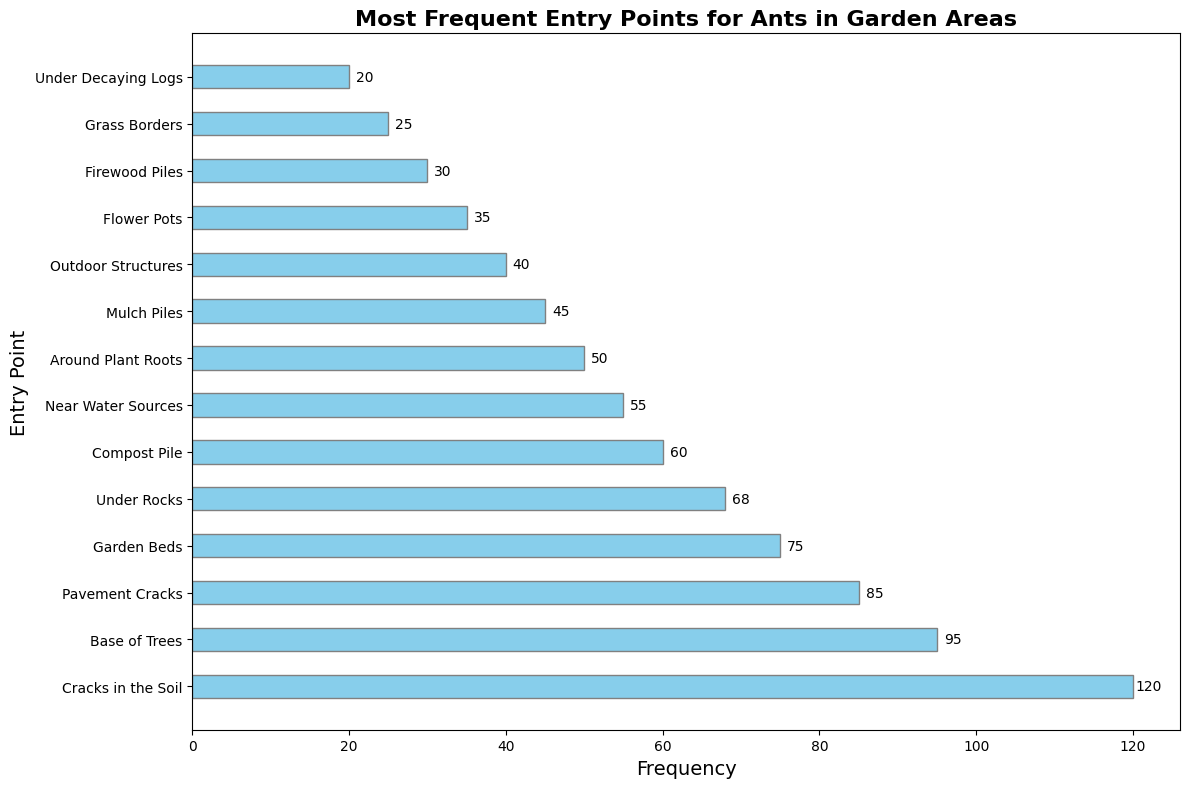Which entry point has the highest frequency? The bar chart shows that "Cracks in the Soil" has the longest bar, indicating the highest frequency.
Answer: Cracks in the Soil How many more ants enter through pavement cracks compared to garden beds? The frequencies are 85 for Pavement Cracks and 75 for Garden Beds. Subtracting 75 from 85 gives: 85 - 75 = 10.
Answer: 10 Which entry point has the lowest frequency? The shortest bar in the chart corresponds to "Under Decaying Logs" with a frequency of 20.
Answer: Under Decaying Logs What is the total frequency for the top three entry points? The top three entry points are Cracks in the Soil (120), Base of Trees (95), and Pavement Cracks (85). Summing these gives: 120 + 95 + 85 = 300.
Answer: 300 Are more ants entering through compost piles or flower pots? The bar for Compost Pile (60) is longer than the bar for Flower Pots (35).
Answer: Compost Pile What's the sum of the frequencies for the entry points under rocks and around plant roots? The frequencies for Under Rocks and Around Plant Roots are 68 and 50 respectively. Summing these gives: 68 + 50 = 118.
Answer: 118 Which has a higher frequency: ants entering near water sources or outdoor structures? The frequency for Near Water Sources is 55, and for Outdoor Structures, it is 40. 55 is higher than 40.
Answer: Near Water Sources What's the average frequency of the three lowest entry points? The three lowest frequencies are Firewood Piles (30), Grass Borders (25), and Under Decaying Logs (20). Their sum is 30 + 25 + 20 = 75, and the average is 75 / 3 = 25.
Answer: 25 